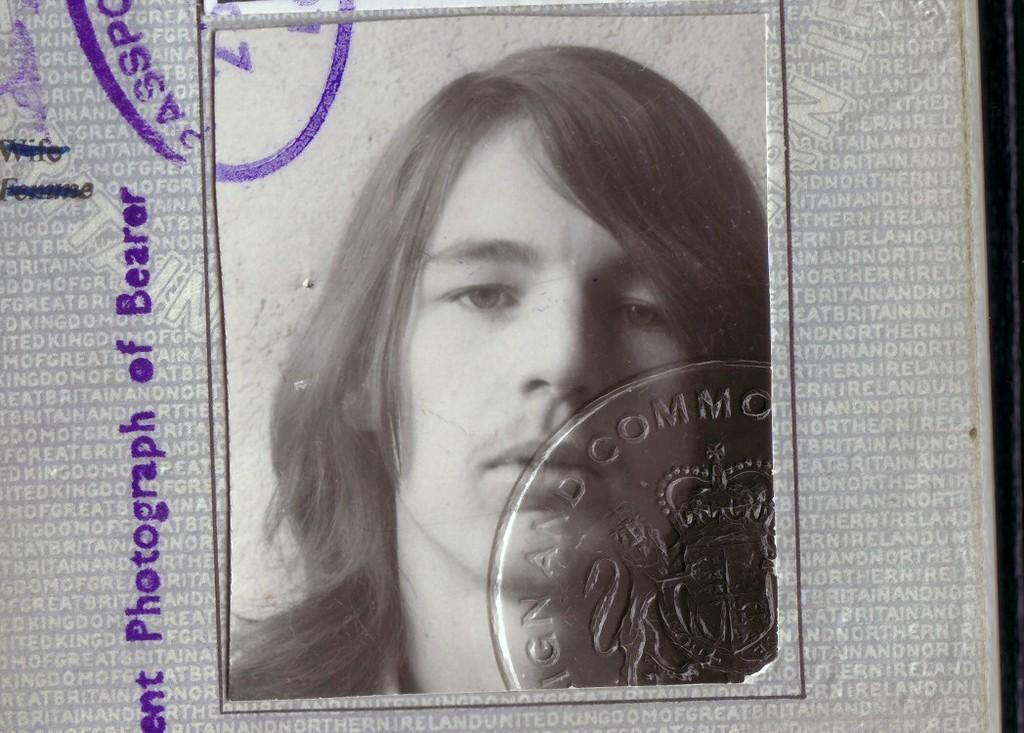What is the color scheme of the photograph? A: The photograph is black and white. Who or what is the main subject of the photograph? The photograph depicts a person. Are there any additional elements on the photograph? Yes, there is a stamp on the photograph. How does the person in the photograph help reduce pollution? The photograph does not provide any information about the person's actions or their impact on pollution. 